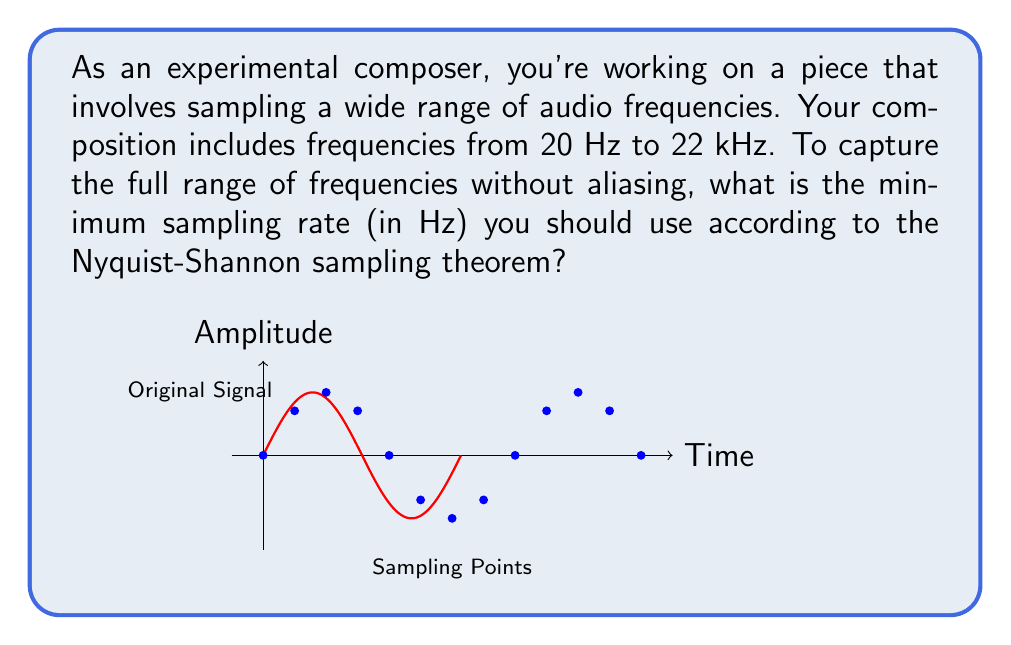Solve this math problem. To determine the optimal sampling rate, we need to apply the Nyquist-Shannon sampling theorem. This theorem states that to accurately reconstruct a continuous signal from its samples, the sampling rate must be at least twice the highest frequency component in the signal.

Let's approach this step-by-step:

1. Identify the highest frequency in the given range:
   The frequency range is from 20 Hz to 22 kHz (22,000 Hz).
   The highest frequency, $f_{max} = 22,000 \text{ Hz}$

2. Apply the Nyquist-Shannon theorem:
   The minimum sampling rate, $f_s$, should be:
   
   $$f_s \geq 2 \times f_{max}$$

3. Calculate the minimum sampling rate:
   $$f_s \geq 2 \times 22,000 \text{ Hz}$$
   $$f_s \geq 44,000 \text{ Hz}$$

Therefore, to capture all frequencies up to 22 kHz without aliasing, you need to sample at a rate of at least 44,000 Hz (or 44 kHz).

In practice, audio engineers often use a slightly higher sampling rate to account for the limitations of anti-aliasing filters. Common sampling rates in digital audio include 44.1 kHz (used for CDs) and 48 kHz (used in digital video).
Answer: 44,000 Hz 